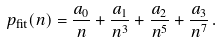Convert formula to latex. <formula><loc_0><loc_0><loc_500><loc_500>p _ { \text {fit} } ( n ) = \frac { a _ { 0 } } { n } + \frac { a _ { 1 } } { n ^ { 3 } } + \frac { a _ { 2 } } { n ^ { 5 } } + \frac { a _ { 3 } } { n ^ { 7 } } \, .</formula> 